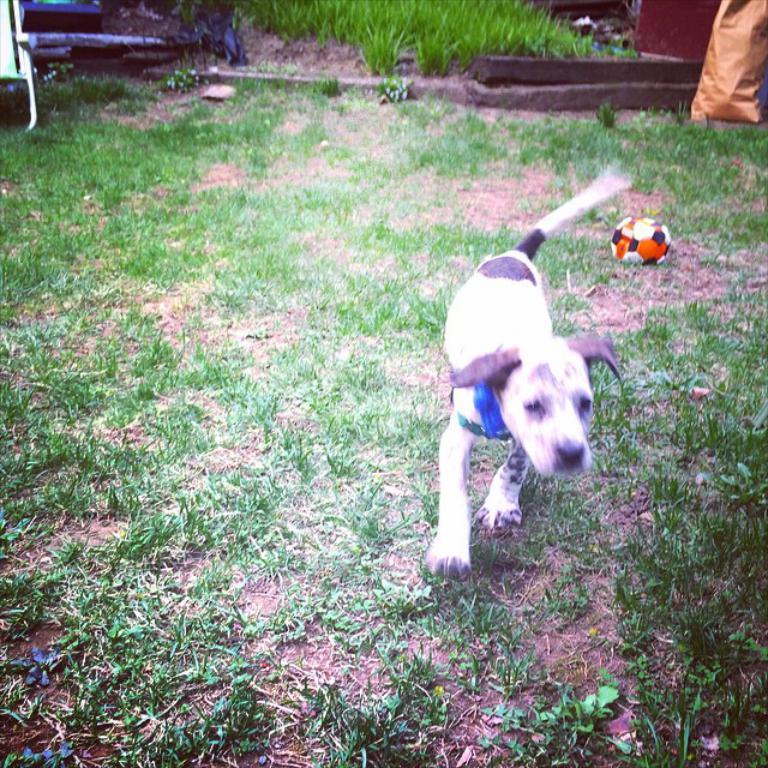Describe this image in one or two sentences. In this picture we can see a dog running and a ball on the ground, grass, bag and in the background we can see plants. 